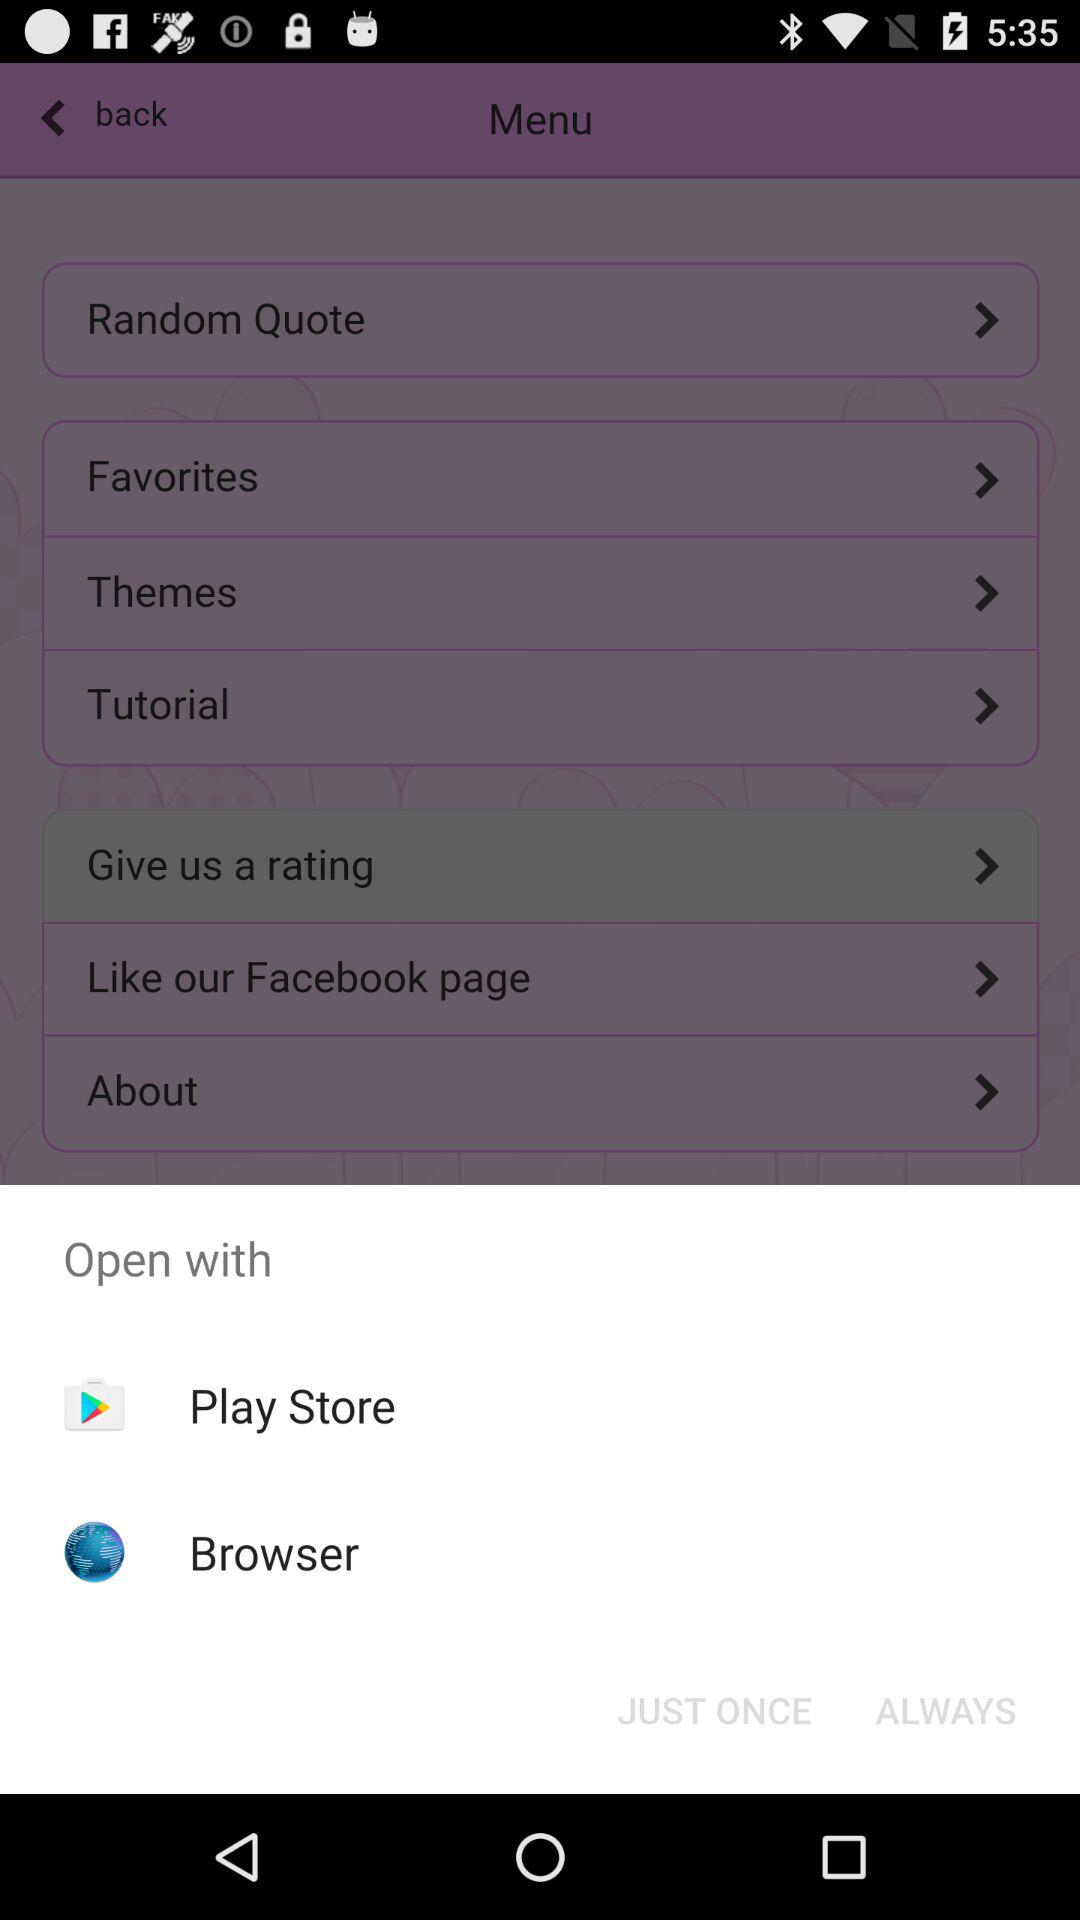How many options are available to open with?
When the provided information is insufficient, respond with <no answer>. <no answer> 